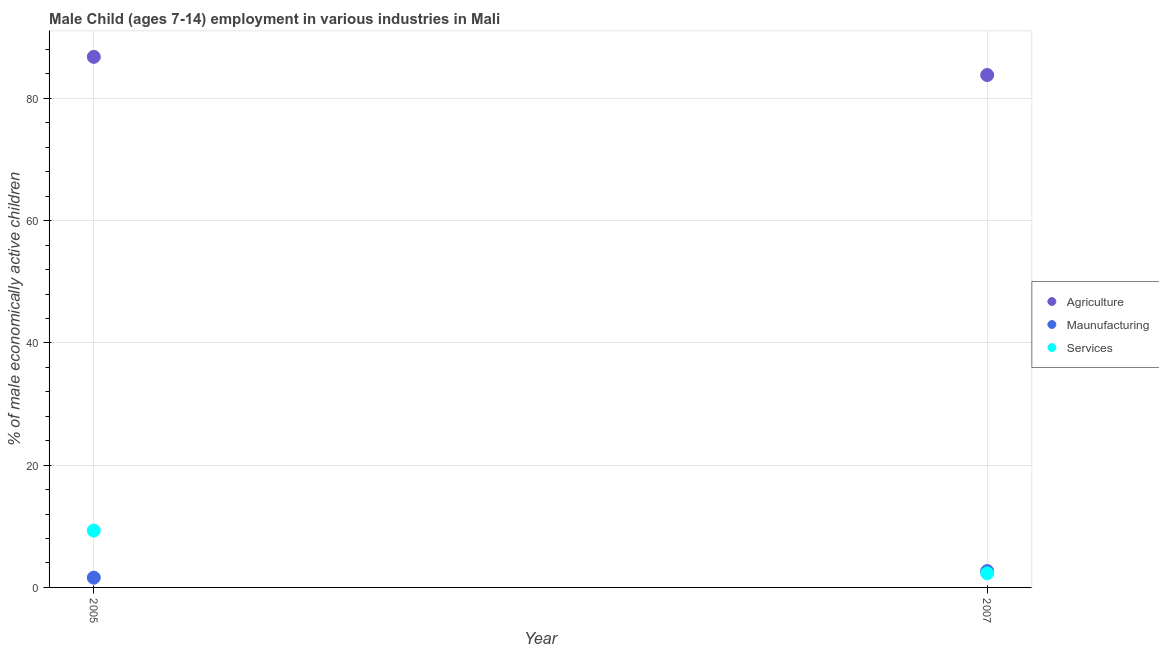How many different coloured dotlines are there?
Make the answer very short. 3. Across all years, what is the maximum percentage of economically active children in manufacturing?
Ensure brevity in your answer.  2.67. Across all years, what is the minimum percentage of economically active children in services?
Provide a succinct answer. 2.31. In which year was the percentage of economically active children in agriculture maximum?
Keep it short and to the point. 2005. In which year was the percentage of economically active children in manufacturing minimum?
Make the answer very short. 2005. What is the total percentage of economically active children in services in the graph?
Provide a short and direct response. 11.61. What is the difference between the percentage of economically active children in manufacturing in 2005 and that in 2007?
Your response must be concise. -1.07. What is the difference between the percentage of economically active children in manufacturing in 2007 and the percentage of economically active children in agriculture in 2005?
Ensure brevity in your answer.  -84.13. What is the average percentage of economically active children in manufacturing per year?
Keep it short and to the point. 2.13. In the year 2007, what is the difference between the percentage of economically active children in services and percentage of economically active children in agriculture?
Your response must be concise. -81.52. In how many years, is the percentage of economically active children in manufacturing greater than 20 %?
Your response must be concise. 0. What is the ratio of the percentage of economically active children in manufacturing in 2005 to that in 2007?
Your answer should be very brief. 0.6. Is the percentage of economically active children in manufacturing in 2005 less than that in 2007?
Provide a succinct answer. Yes. In how many years, is the percentage of economically active children in services greater than the average percentage of economically active children in services taken over all years?
Offer a terse response. 1. Is it the case that in every year, the sum of the percentage of economically active children in agriculture and percentage of economically active children in manufacturing is greater than the percentage of economically active children in services?
Your answer should be very brief. Yes. Does the percentage of economically active children in agriculture monotonically increase over the years?
Your answer should be very brief. No. How many dotlines are there?
Offer a terse response. 3. How many years are there in the graph?
Offer a very short reply. 2. Does the graph contain grids?
Your answer should be compact. Yes. Where does the legend appear in the graph?
Your answer should be very brief. Center right. What is the title of the graph?
Offer a terse response. Male Child (ages 7-14) employment in various industries in Mali. What is the label or title of the Y-axis?
Your response must be concise. % of male economically active children. What is the % of male economically active children of Agriculture in 2005?
Provide a short and direct response. 86.8. What is the % of male economically active children in Maunufacturing in 2005?
Provide a succinct answer. 1.6. What is the % of male economically active children of Agriculture in 2007?
Your answer should be very brief. 83.83. What is the % of male economically active children of Maunufacturing in 2007?
Make the answer very short. 2.67. What is the % of male economically active children of Services in 2007?
Your answer should be compact. 2.31. Across all years, what is the maximum % of male economically active children of Agriculture?
Provide a succinct answer. 86.8. Across all years, what is the maximum % of male economically active children of Maunufacturing?
Give a very brief answer. 2.67. Across all years, what is the minimum % of male economically active children of Agriculture?
Your answer should be very brief. 83.83. Across all years, what is the minimum % of male economically active children of Services?
Offer a very short reply. 2.31. What is the total % of male economically active children in Agriculture in the graph?
Keep it short and to the point. 170.63. What is the total % of male economically active children in Maunufacturing in the graph?
Your answer should be compact. 4.27. What is the total % of male economically active children in Services in the graph?
Ensure brevity in your answer.  11.61. What is the difference between the % of male economically active children of Agriculture in 2005 and that in 2007?
Your answer should be compact. 2.97. What is the difference between the % of male economically active children in Maunufacturing in 2005 and that in 2007?
Offer a terse response. -1.07. What is the difference between the % of male economically active children in Services in 2005 and that in 2007?
Your answer should be compact. 6.99. What is the difference between the % of male economically active children in Agriculture in 2005 and the % of male economically active children in Maunufacturing in 2007?
Offer a very short reply. 84.13. What is the difference between the % of male economically active children in Agriculture in 2005 and the % of male economically active children in Services in 2007?
Your answer should be compact. 84.49. What is the difference between the % of male economically active children of Maunufacturing in 2005 and the % of male economically active children of Services in 2007?
Provide a short and direct response. -0.71. What is the average % of male economically active children in Agriculture per year?
Provide a short and direct response. 85.31. What is the average % of male economically active children in Maunufacturing per year?
Your answer should be compact. 2.13. What is the average % of male economically active children in Services per year?
Provide a succinct answer. 5.8. In the year 2005, what is the difference between the % of male economically active children of Agriculture and % of male economically active children of Maunufacturing?
Ensure brevity in your answer.  85.2. In the year 2005, what is the difference between the % of male economically active children in Agriculture and % of male economically active children in Services?
Offer a terse response. 77.5. In the year 2005, what is the difference between the % of male economically active children of Maunufacturing and % of male economically active children of Services?
Make the answer very short. -7.7. In the year 2007, what is the difference between the % of male economically active children of Agriculture and % of male economically active children of Maunufacturing?
Keep it short and to the point. 81.16. In the year 2007, what is the difference between the % of male economically active children of Agriculture and % of male economically active children of Services?
Your response must be concise. 81.52. In the year 2007, what is the difference between the % of male economically active children of Maunufacturing and % of male economically active children of Services?
Your response must be concise. 0.36. What is the ratio of the % of male economically active children of Agriculture in 2005 to that in 2007?
Make the answer very short. 1.04. What is the ratio of the % of male economically active children in Maunufacturing in 2005 to that in 2007?
Offer a very short reply. 0.6. What is the ratio of the % of male economically active children of Services in 2005 to that in 2007?
Your answer should be very brief. 4.03. What is the difference between the highest and the second highest % of male economically active children of Agriculture?
Offer a terse response. 2.97. What is the difference between the highest and the second highest % of male economically active children of Maunufacturing?
Your answer should be very brief. 1.07. What is the difference between the highest and the second highest % of male economically active children of Services?
Your answer should be compact. 6.99. What is the difference between the highest and the lowest % of male economically active children of Agriculture?
Offer a very short reply. 2.97. What is the difference between the highest and the lowest % of male economically active children of Maunufacturing?
Your response must be concise. 1.07. What is the difference between the highest and the lowest % of male economically active children in Services?
Offer a very short reply. 6.99. 